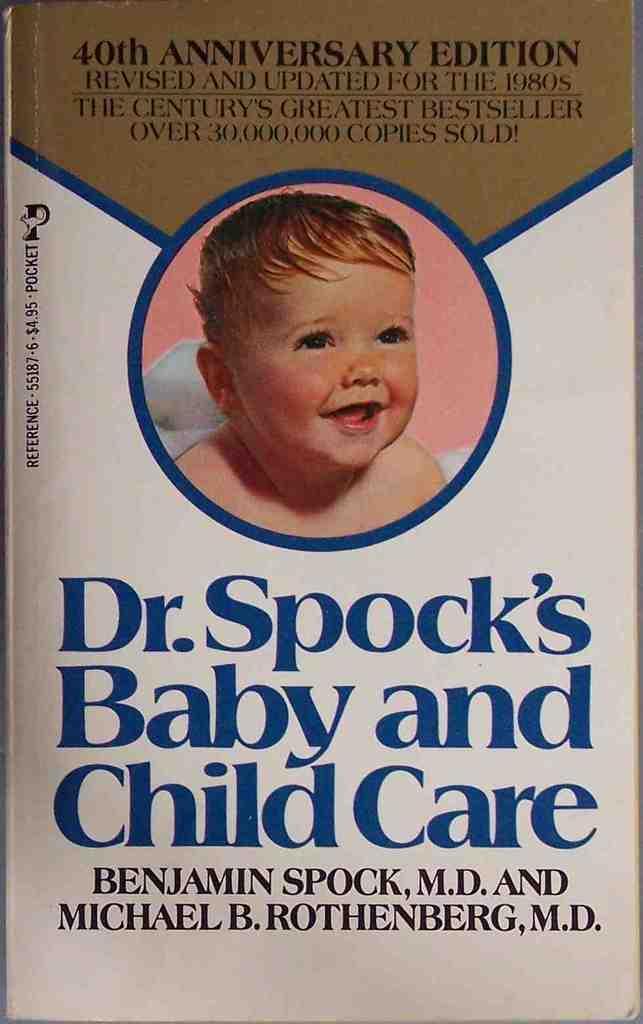Please provide a concise description of this image. In this image we can see a poster. In this poster many things are written. Also there is an image of a baby. 